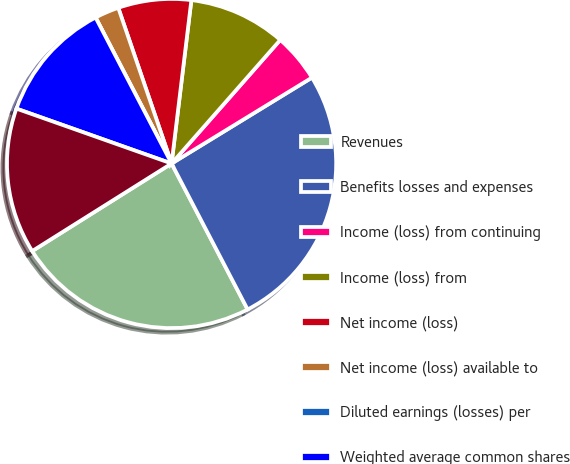<chart> <loc_0><loc_0><loc_500><loc_500><pie_chart><fcel>Revenues<fcel>Benefits losses and expenses<fcel>Income (loss) from continuing<fcel>Income (loss) from<fcel>Net income (loss)<fcel>Net income (loss) available to<fcel>Diluted earnings (losses) per<fcel>Weighted average common shares<fcel>Weighted average shares<nl><fcel>23.72%<fcel>26.1%<fcel>4.78%<fcel>9.56%<fcel>7.17%<fcel>2.39%<fcel>0.0%<fcel>11.95%<fcel>14.34%<nl></chart> 